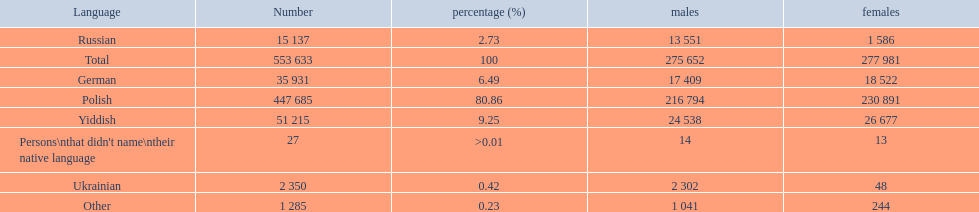What are all of the languages? Polish, Yiddish, German, Russian, Ukrainian, Other, Persons\nthat didn't name\ntheir native language. And how many people speak these languages? 447 685, 51 215, 35 931, 15 137, 2 350, 1 285, 27. Which language is used by most people? Polish. 